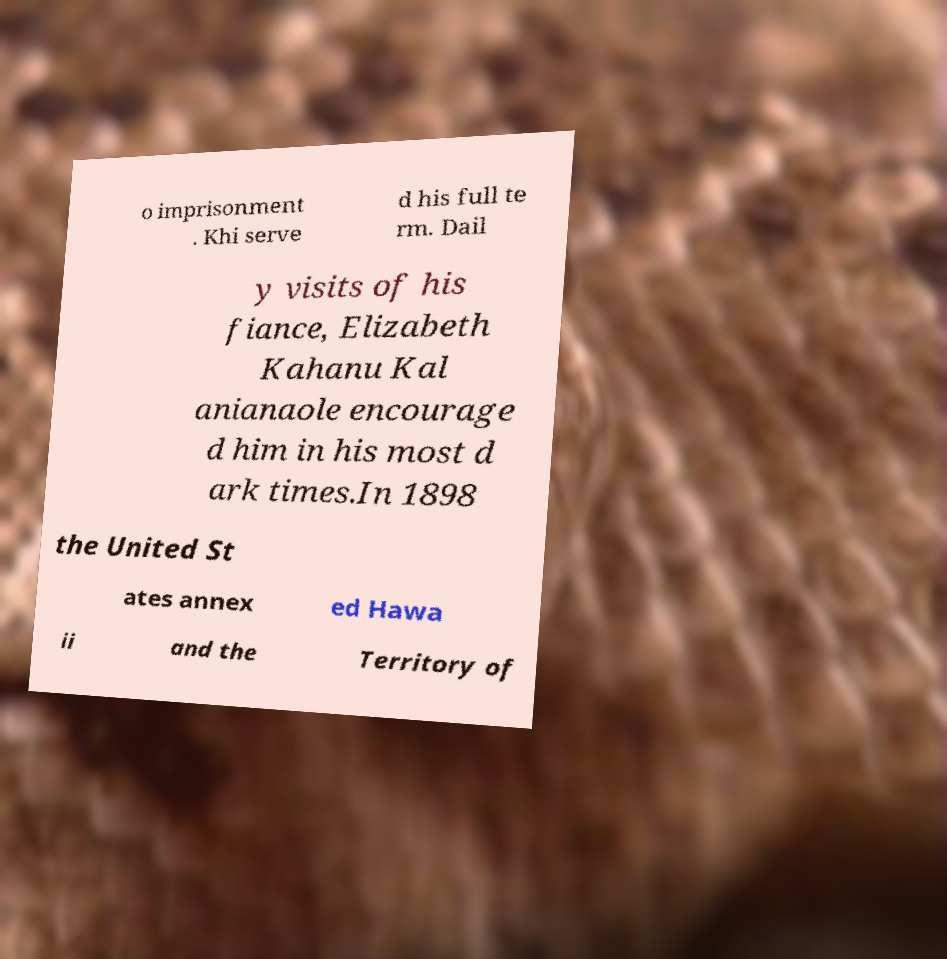Could you assist in decoding the text presented in this image and type it out clearly? o imprisonment . Khi serve d his full te rm. Dail y visits of his fiance, Elizabeth Kahanu Kal anianaole encourage d him in his most d ark times.In 1898 the United St ates annex ed Hawa ii and the Territory of 